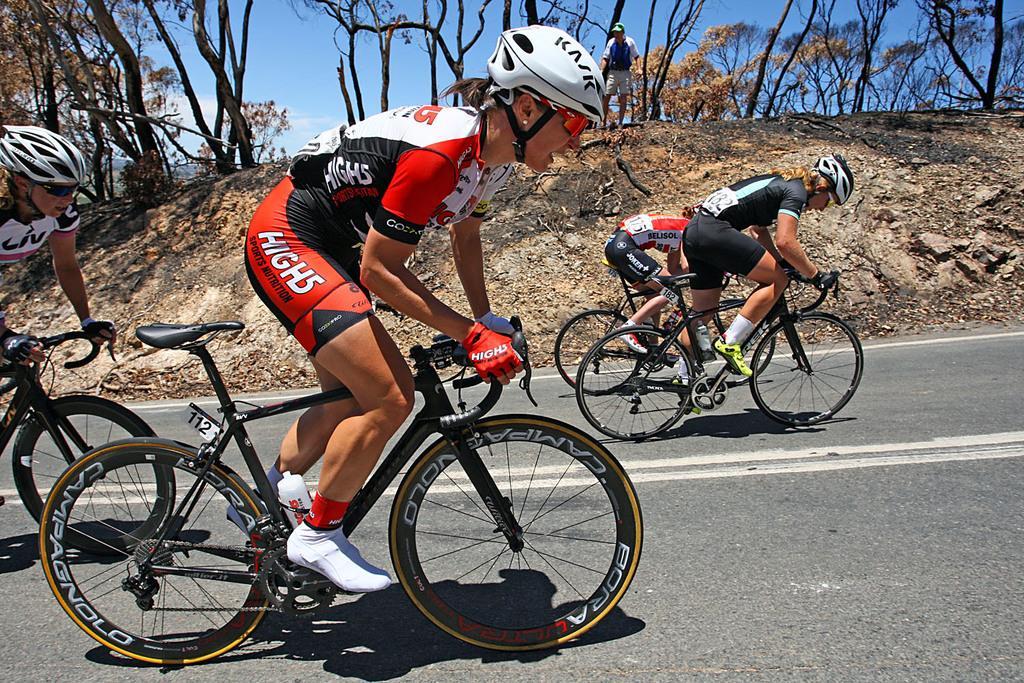Can you describe this image briefly? This image consists of four women riding bicycles. They are wearing helmets and gloves. At the bottom, there is a road. In the background, we can see many trees and a man standing. At the top, there is sky. 